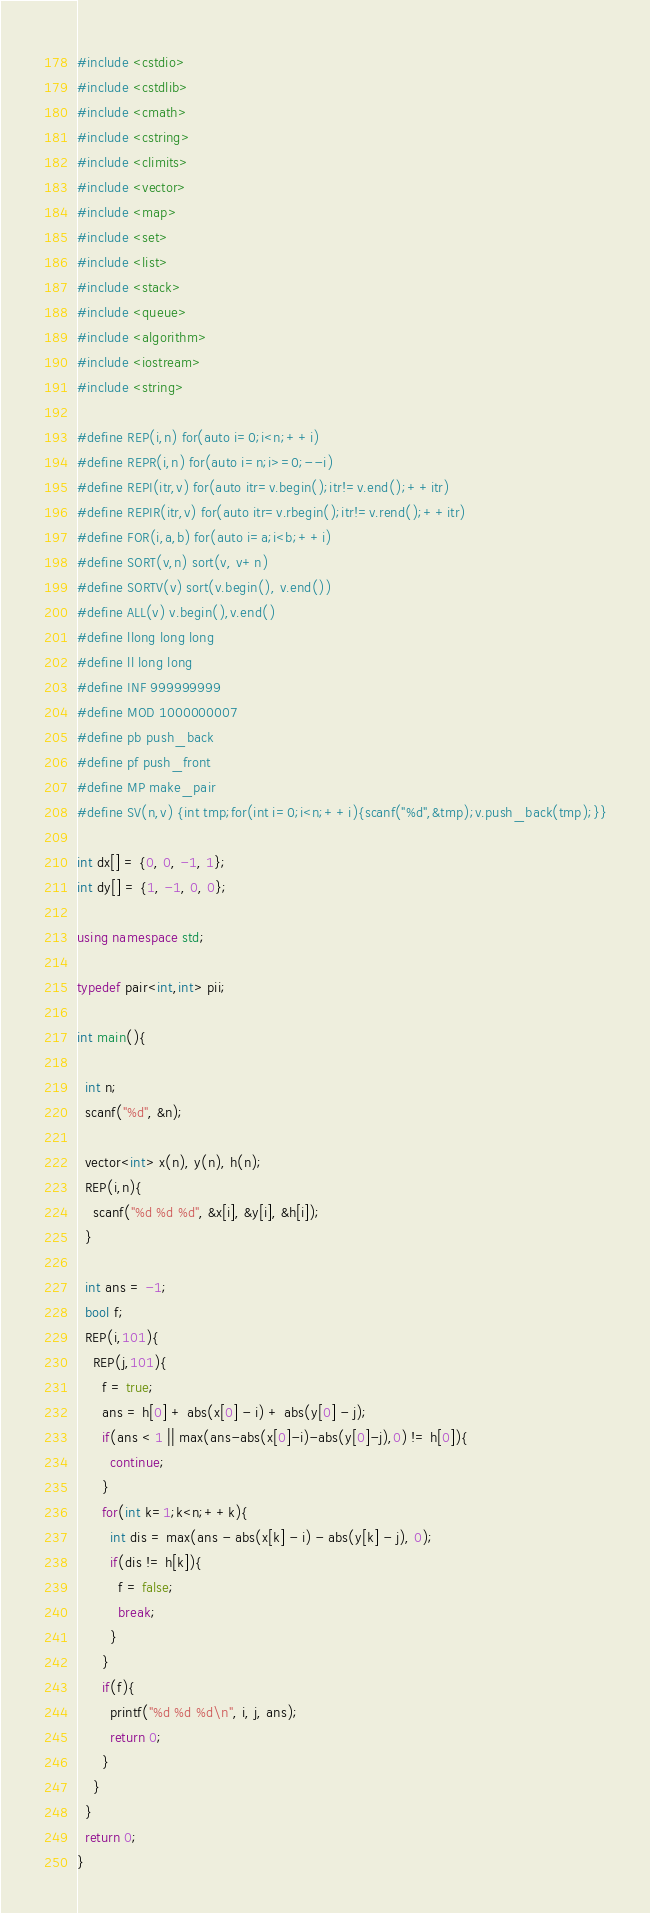<code> <loc_0><loc_0><loc_500><loc_500><_C++_>#include <cstdio>
#include <cstdlib>
#include <cmath>
#include <cstring>
#include <climits>
#include <vector>
#include <map>
#include <set>
#include <list>
#include <stack>
#include <queue>
#include <algorithm>
#include <iostream>
#include <string>

#define REP(i,n) for(auto i=0;i<n;++i)
#define REPR(i,n) for(auto i=n;i>=0;--i)
#define REPI(itr,v) for(auto itr=v.begin();itr!=v.end();++itr)
#define REPIR(itr,v) for(auto itr=v.rbegin();itr!=v.rend();++itr)
#define FOR(i,a,b) for(auto i=a;i<b;++i)
#define SORT(v,n) sort(v, v+n)
#define SORTV(v) sort(v.begin(), v.end())
#define ALL(v) v.begin(),v.end()
#define llong long long
#define ll long long
#define INF 999999999
#define MOD 1000000007
#define pb push_back
#define pf push_front
#define MP make_pair
#define SV(n,v) {int tmp;for(int i=0;i<n;++i){scanf("%d",&tmp);v.push_back(tmp);}}

int dx[] = {0, 0, -1, 1};
int dy[] = {1, -1, 0, 0};

using namespace std;

typedef pair<int,int> pii;

int main(){

  int n;
  scanf("%d", &n);

  vector<int> x(n), y(n), h(n);
  REP(i,n){
    scanf("%d %d %d", &x[i], &y[i], &h[i]);
  }

  int ans = -1;
  bool f;
  REP(i,101){
    REP(j,101){
      f = true;
      ans = h[0] + abs(x[0] - i) + abs(y[0] - j);
      if(ans < 1 || max(ans-abs(x[0]-i)-abs(y[0]-j),0) != h[0]){
        continue;
      }
      for(int k=1;k<n;++k){
        int dis = max(ans - abs(x[k] - i) - abs(y[k] - j), 0);
        if(dis != h[k]){
          f = false;
          break;
        }
      }
      if(f){
        printf("%d %d %d\n", i, j, ans);
        return 0;
      }
    }
  }
  return 0;
}

</code> 